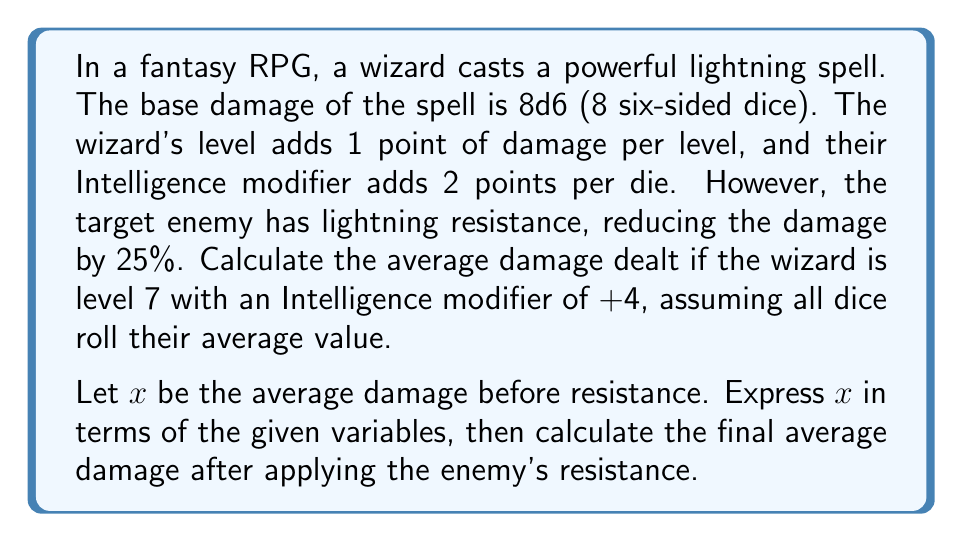Help me with this question. Let's break this down step-by-step:

1) First, we need to calculate the average roll of a d6 (six-sided die):
   $\text{Average d6} = \frac{1 + 2 + 3 + 4 + 5 + 6}{6} = \frac{21}{6} = 3.5$

2) Now, let's set up our equation for $x$ (average damage before resistance):
   $$x = 8 \cdot (3.5 + 2) + 7 + (8 \cdot 4)$$

   Here's what each part means:
   - $8 \cdot (3.5 + 2)$: 8 dice, each doing 3.5 (average) + 2 (Int modifier per die)
   - $7$: Wizard's level added to damage
   - $(8 \cdot 4)$: Intelligence modifier (+4) applied to each die

3) Let's solve for $x$:
   $$x = 8 \cdot 5.5 + 7 + 32$$
   $$x = 44 + 7 + 32 = 83$$

4) Now that we have the average damage before resistance, we need to apply the 25% resistance:
   Final damage $= x \cdot (1 - 0.25) = 83 \cdot 0.75 = 62.25$

Therefore, the average damage after applying the enemy's resistance is 62.25.
Answer: 62.25 points of damage 